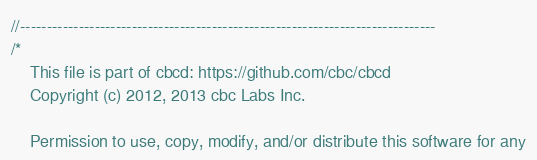Convert code to text. <code><loc_0><loc_0><loc_500><loc_500><_C++_>//------------------------------------------------------------------------------
/*
    This file is part of cbcd: https://github.com/cbc/cbcd
    Copyright (c) 2012, 2013 cbc Labs Inc.

    Permission to use, copy, modify, and/or distribute this software for any</code> 